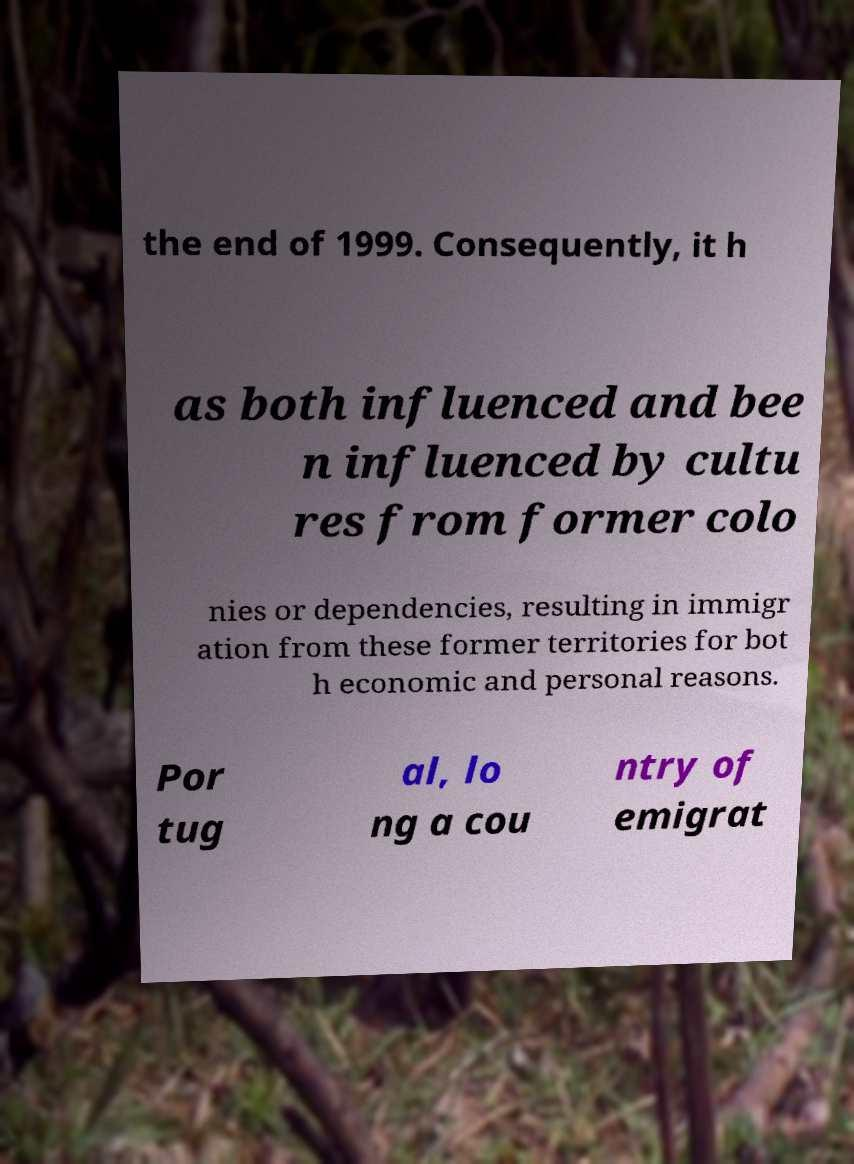Please read and relay the text visible in this image. What does it say? the end of 1999. Consequently, it h as both influenced and bee n influenced by cultu res from former colo nies or dependencies, resulting in immigr ation from these former territories for bot h economic and personal reasons. Por tug al, lo ng a cou ntry of emigrat 